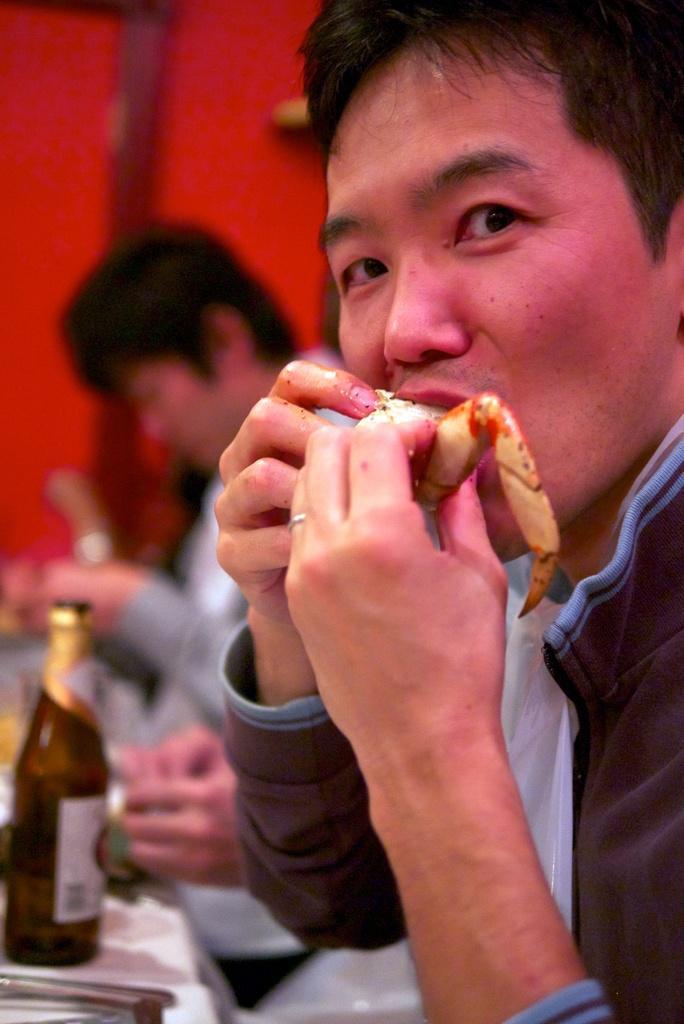Could you give a brief overview of what you see in this image? In this image I can see two people. Among them one person is eating something. In front of them there is a bottle on the table. 